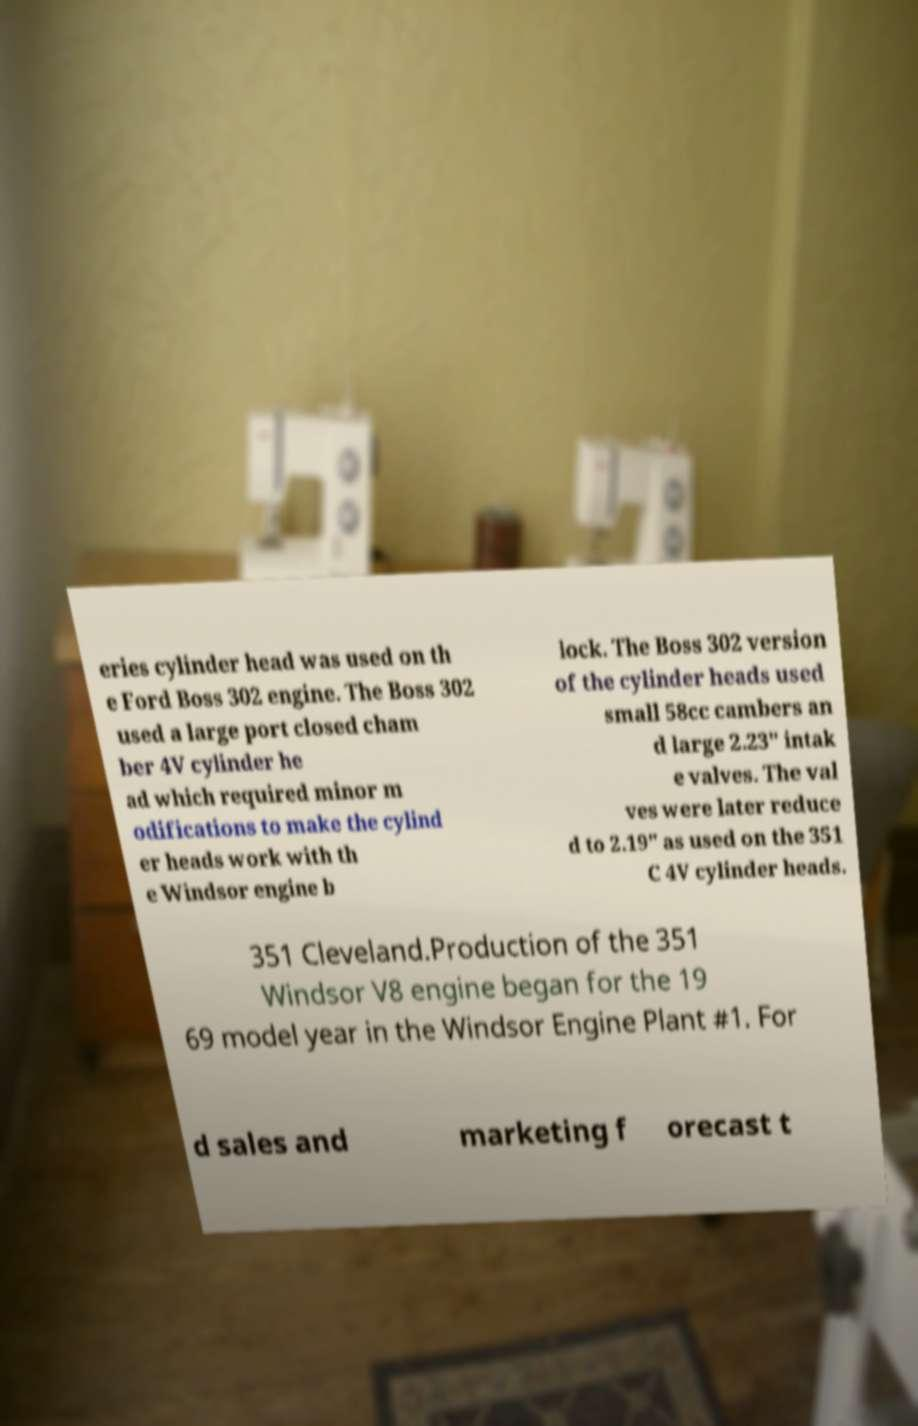What messages or text are displayed in this image? I need them in a readable, typed format. eries cylinder head was used on th e Ford Boss 302 engine. The Boss 302 used a large port closed cham ber 4V cylinder he ad which required minor m odifications to make the cylind er heads work with th e Windsor engine b lock. The Boss 302 version of the cylinder heads used small 58cc cambers an d large 2.23" intak e valves. The val ves were later reduce d to 2.19" as used on the 351 C 4V cylinder heads. 351 Cleveland.Production of the 351 Windsor V8 engine began for the 19 69 model year in the Windsor Engine Plant #1. For d sales and marketing f orecast t 